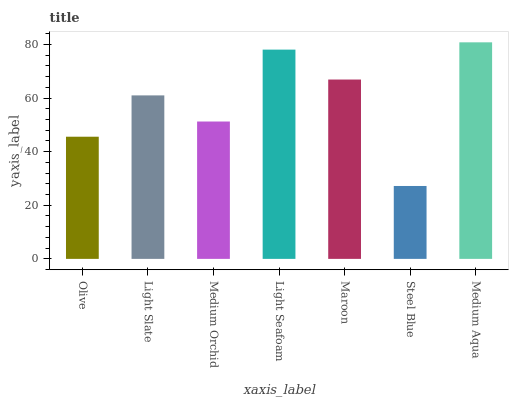Is Steel Blue the minimum?
Answer yes or no. Yes. Is Medium Aqua the maximum?
Answer yes or no. Yes. Is Light Slate the minimum?
Answer yes or no. No. Is Light Slate the maximum?
Answer yes or no. No. Is Light Slate greater than Olive?
Answer yes or no. Yes. Is Olive less than Light Slate?
Answer yes or no. Yes. Is Olive greater than Light Slate?
Answer yes or no. No. Is Light Slate less than Olive?
Answer yes or no. No. Is Light Slate the high median?
Answer yes or no. Yes. Is Light Slate the low median?
Answer yes or no. Yes. Is Medium Aqua the high median?
Answer yes or no. No. Is Maroon the low median?
Answer yes or no. No. 